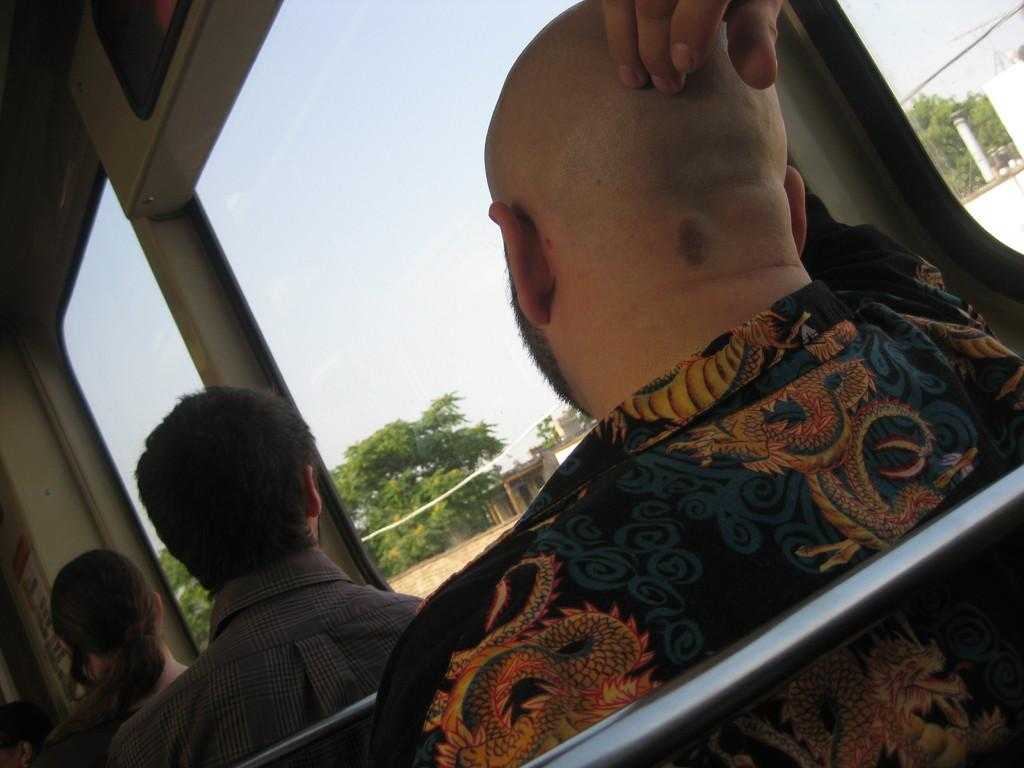What are the people in the image doing? The people in the image are sitting on a vehicle. What can be seen in the image besides the people and the vehicle? There are trees visible in the image. What is visible in the background of the image? The sky and buildings are visible in the background of the image. What type of lumber is being transported by the vehicle in the image? There is no lumber visible in the image, and it is not mentioned that the vehicle is transporting any lumber. 